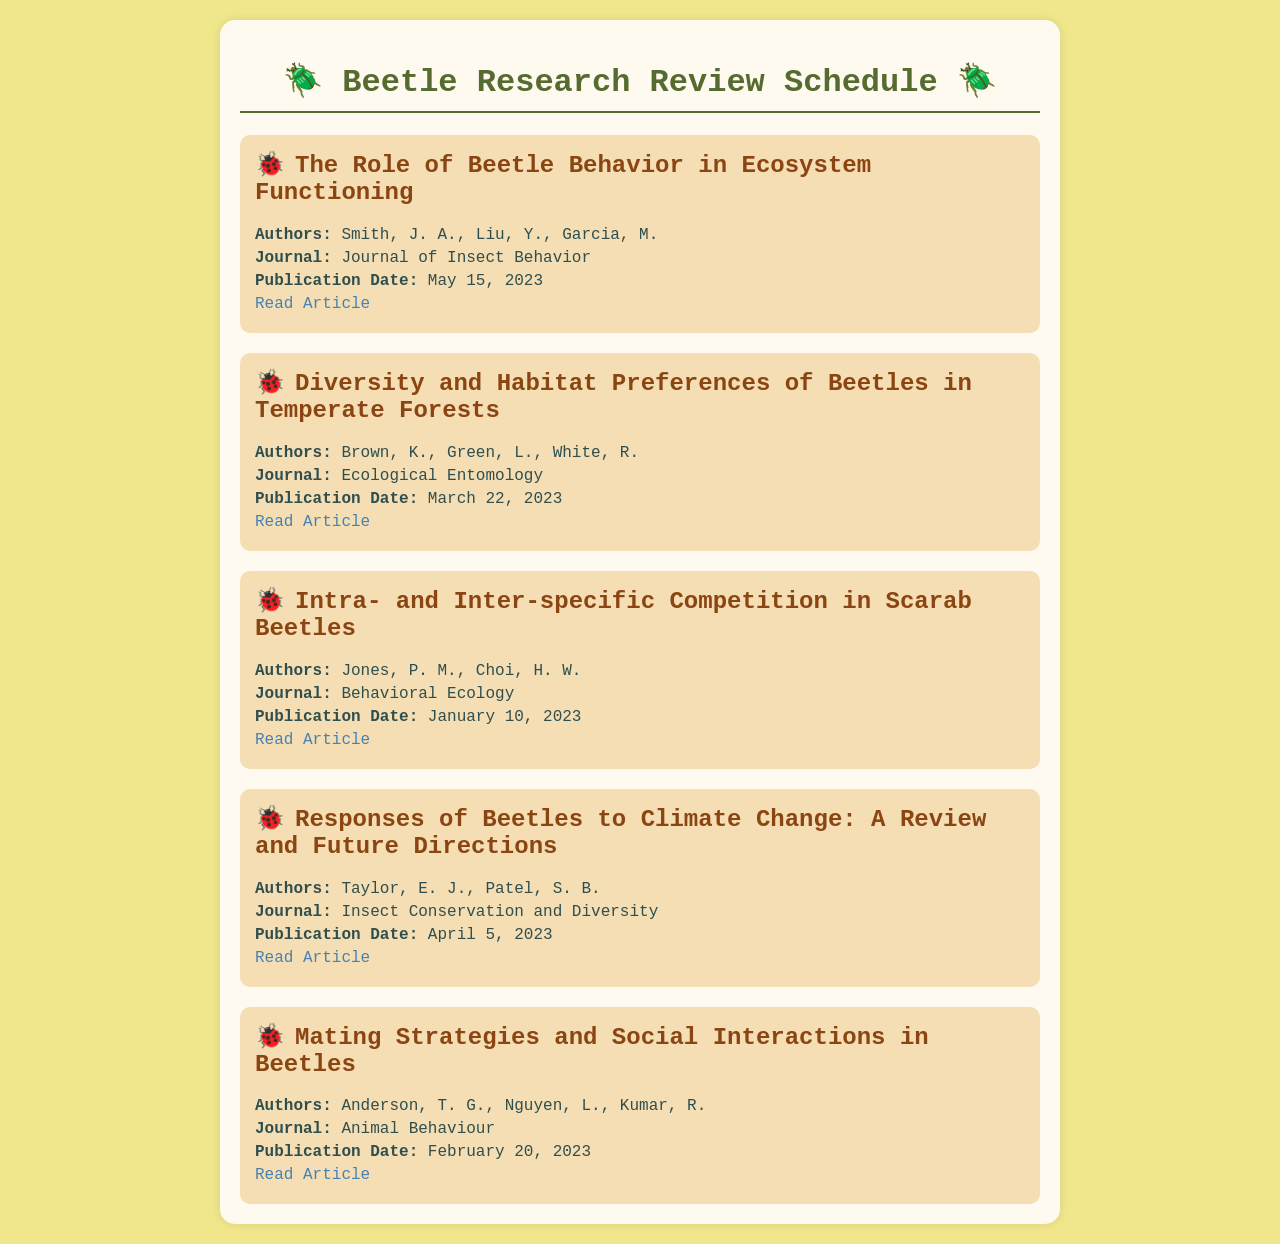What is the title of the first publication? The title of the first publication is the first line of the first publication entry in the document.
Answer: The Role of Beetle Behavior in Ecosystem Functioning Who are the authors of the article published on April 5, 2023? The authors are listed under the publication title, specifically for the article dated April 5, 2023.
Answer: Taylor, E. J., Patel, S. B Which journal published the article on March 22, 2023? The journal's name is mentioned in the publication details of the article published on that date.
Answer: Ecological Entomology How many articles are listed in the schedule? The number of articles is equal to the total number of publication entries in the document.
Answer: 5 What is the publication date of the article discussing mating strategies? The publication date is found within the details of the publication entry related to mating strategies.
Answer: February 20, 2023 Which publication focuses on competition in scarab beetles? This can be determined by matching the topic of the publication to its title listed in the document.
Answer: Intra- and Inter-specific Competition in Scarab Beetles What type of research does the article from the Journal of Insect Behavior discuss? The specific topic can be derived from the title of the publication listed in the document.
Answer: Ecosystem Functioning 